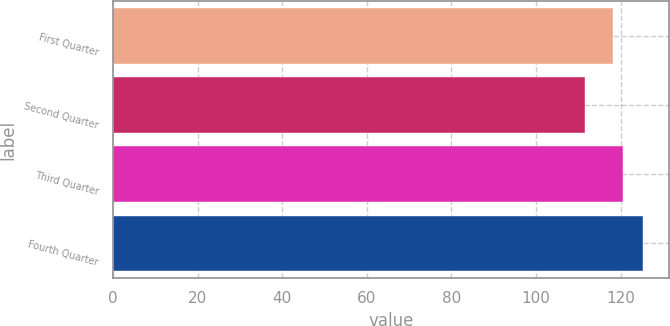<chart> <loc_0><loc_0><loc_500><loc_500><bar_chart><fcel>First Quarter<fcel>Second Quarter<fcel>Third Quarter<fcel>Fourth Quarter<nl><fcel>118.19<fcel>111.55<fcel>120.42<fcel>125.16<nl></chart> 